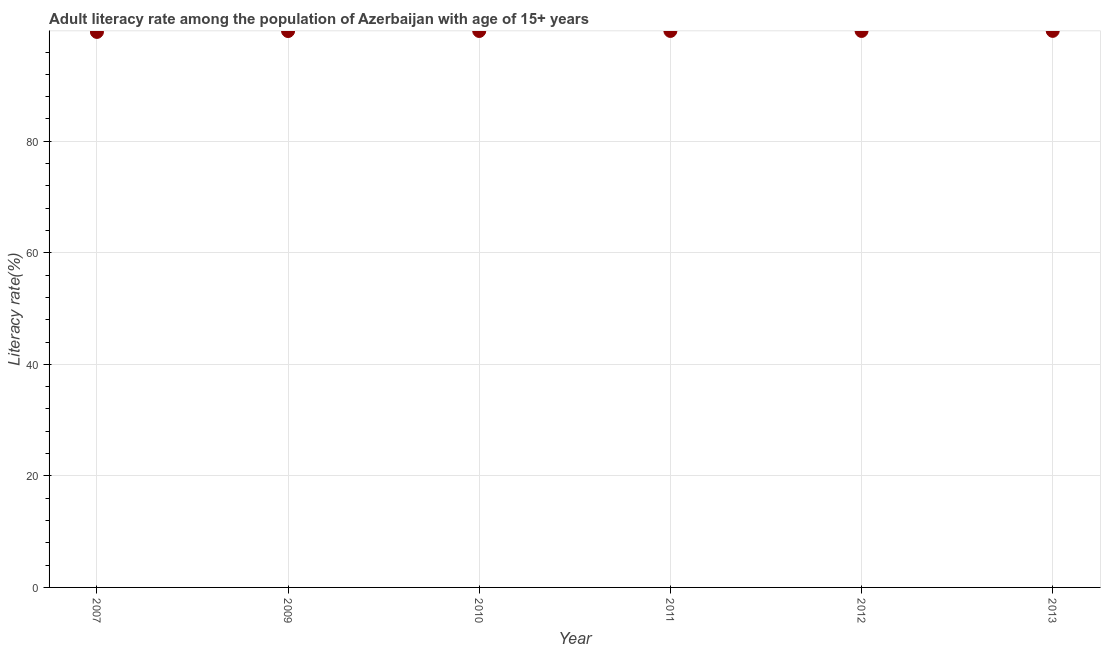What is the adult literacy rate in 2009?
Offer a very short reply. 99.76. Across all years, what is the maximum adult literacy rate?
Give a very brief answer. 99.79. Across all years, what is the minimum adult literacy rate?
Provide a succinct answer. 99.6. What is the sum of the adult literacy rate?
Ensure brevity in your answer.  598.48. What is the difference between the adult literacy rate in 2009 and 2010?
Make the answer very short. -0.01. What is the average adult literacy rate per year?
Your response must be concise. 99.75. What is the median adult literacy rate?
Give a very brief answer. 99.77. In how many years, is the adult literacy rate greater than 88 %?
Offer a terse response. 6. Do a majority of the years between 2011 and 2012 (inclusive) have adult literacy rate greater than 92 %?
Provide a succinct answer. Yes. What is the ratio of the adult literacy rate in 2009 to that in 2012?
Offer a very short reply. 1. Is the adult literacy rate in 2010 less than that in 2013?
Provide a short and direct response. Yes. Is the difference between the adult literacy rate in 2007 and 2011 greater than the difference between any two years?
Your answer should be very brief. No. What is the difference between the highest and the second highest adult literacy rate?
Make the answer very short. 0.01. Is the sum of the adult literacy rate in 2007 and 2010 greater than the maximum adult literacy rate across all years?
Provide a short and direct response. Yes. What is the difference between the highest and the lowest adult literacy rate?
Make the answer very short. 0.19. Does the adult literacy rate monotonically increase over the years?
Your answer should be very brief. No. How many dotlines are there?
Keep it short and to the point. 1. How many years are there in the graph?
Offer a very short reply. 6. Are the values on the major ticks of Y-axis written in scientific E-notation?
Your answer should be very brief. No. Does the graph contain any zero values?
Offer a very short reply. No. What is the title of the graph?
Make the answer very short. Adult literacy rate among the population of Azerbaijan with age of 15+ years. What is the label or title of the Y-axis?
Your answer should be very brief. Literacy rate(%). What is the Literacy rate(%) in 2007?
Give a very brief answer. 99.6. What is the Literacy rate(%) in 2009?
Your answer should be compact. 99.76. What is the Literacy rate(%) in 2010?
Provide a succinct answer. 99.77. What is the Literacy rate(%) in 2011?
Your answer should be very brief. 99.78. What is the Literacy rate(%) in 2012?
Offer a very short reply. 99.78. What is the Literacy rate(%) in 2013?
Your response must be concise. 99.79. What is the difference between the Literacy rate(%) in 2007 and 2009?
Ensure brevity in your answer.  -0.16. What is the difference between the Literacy rate(%) in 2007 and 2010?
Ensure brevity in your answer.  -0.17. What is the difference between the Literacy rate(%) in 2007 and 2011?
Provide a succinct answer. -0.18. What is the difference between the Literacy rate(%) in 2007 and 2012?
Provide a succinct answer. -0.17. What is the difference between the Literacy rate(%) in 2007 and 2013?
Provide a succinct answer. -0.19. What is the difference between the Literacy rate(%) in 2009 and 2010?
Keep it short and to the point. -0.01. What is the difference between the Literacy rate(%) in 2009 and 2011?
Your response must be concise. -0.02. What is the difference between the Literacy rate(%) in 2009 and 2012?
Your response must be concise. -0.02. What is the difference between the Literacy rate(%) in 2009 and 2013?
Make the answer very short. -0.03. What is the difference between the Literacy rate(%) in 2010 and 2011?
Provide a short and direct response. -0.01. What is the difference between the Literacy rate(%) in 2010 and 2012?
Your answer should be very brief. -0. What is the difference between the Literacy rate(%) in 2010 and 2013?
Offer a very short reply. -0.02. What is the difference between the Literacy rate(%) in 2011 and 2012?
Give a very brief answer. 0. What is the difference between the Literacy rate(%) in 2011 and 2013?
Keep it short and to the point. -0.01. What is the difference between the Literacy rate(%) in 2012 and 2013?
Make the answer very short. -0.01. What is the ratio of the Literacy rate(%) in 2007 to that in 2009?
Provide a short and direct response. 1. What is the ratio of the Literacy rate(%) in 2007 to that in 2012?
Your answer should be very brief. 1. What is the ratio of the Literacy rate(%) in 2007 to that in 2013?
Make the answer very short. 1. What is the ratio of the Literacy rate(%) in 2009 to that in 2011?
Provide a succinct answer. 1. What is the ratio of the Literacy rate(%) in 2009 to that in 2012?
Your answer should be compact. 1. What is the ratio of the Literacy rate(%) in 2010 to that in 2013?
Your response must be concise. 1. What is the ratio of the Literacy rate(%) in 2011 to that in 2013?
Your answer should be very brief. 1. 